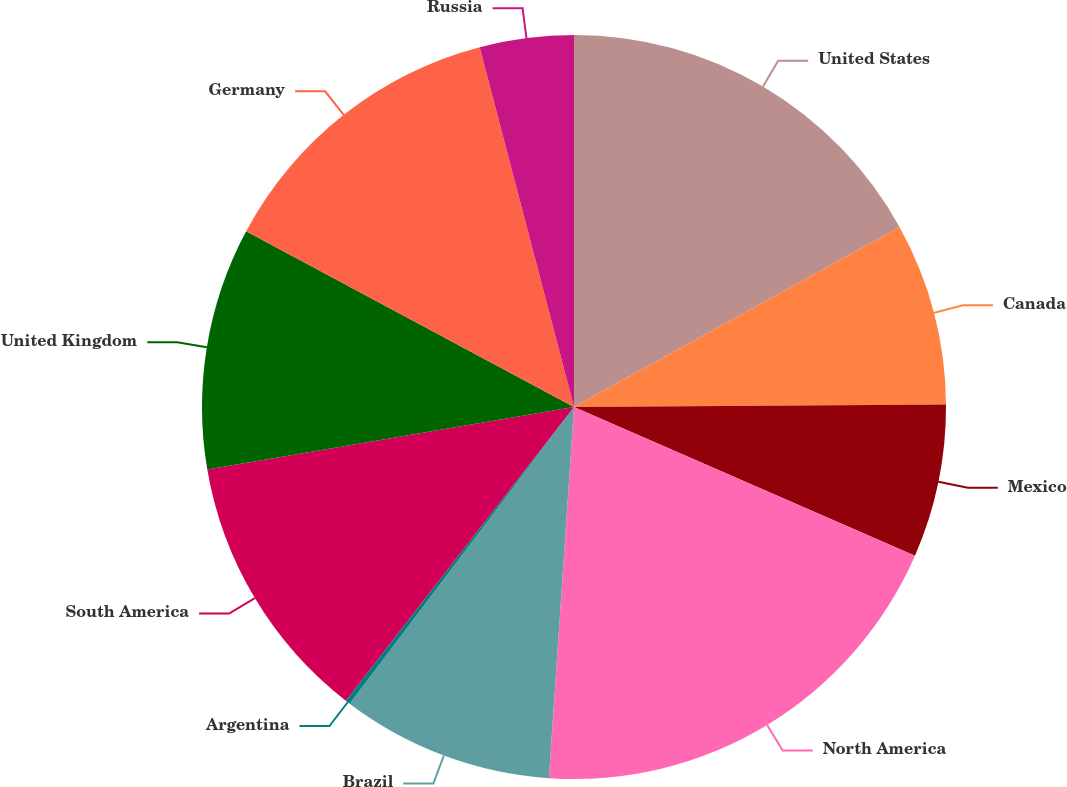Convert chart. <chart><loc_0><loc_0><loc_500><loc_500><pie_chart><fcel>United States<fcel>Canada<fcel>Mexico<fcel>North America<fcel>Brazil<fcel>Argentina<fcel>South America<fcel>United Kingdom<fcel>Germany<fcel>Russia<nl><fcel>16.96%<fcel>7.94%<fcel>6.65%<fcel>19.53%<fcel>9.23%<fcel>0.21%<fcel>11.8%<fcel>10.52%<fcel>13.09%<fcel>4.08%<nl></chart> 